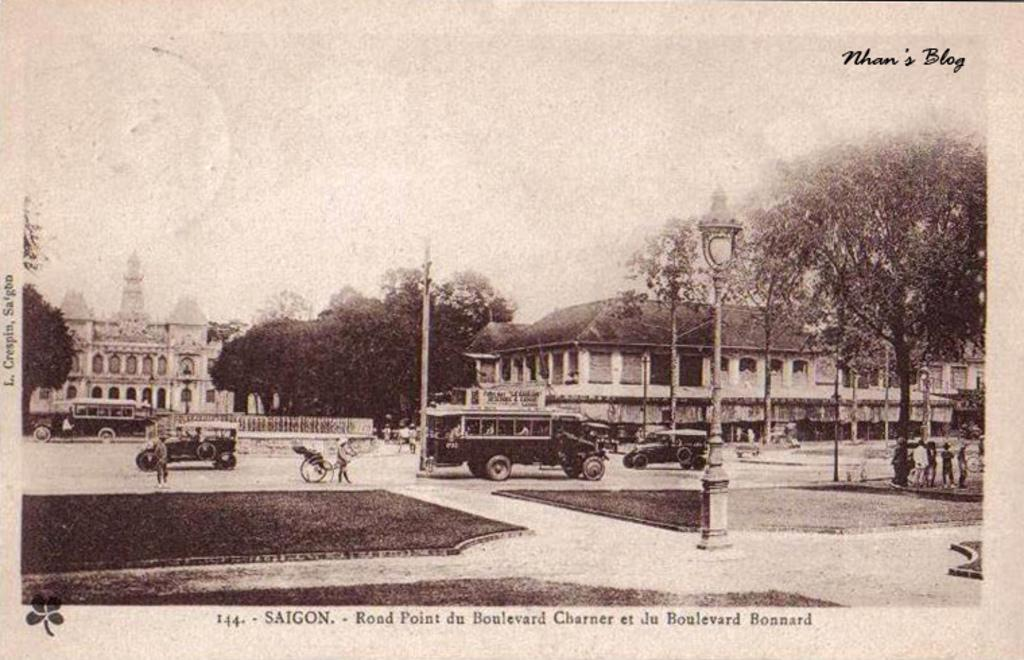<image>
Write a terse but informative summary of the picture. An old photograph shows a street scene in Siagon. 